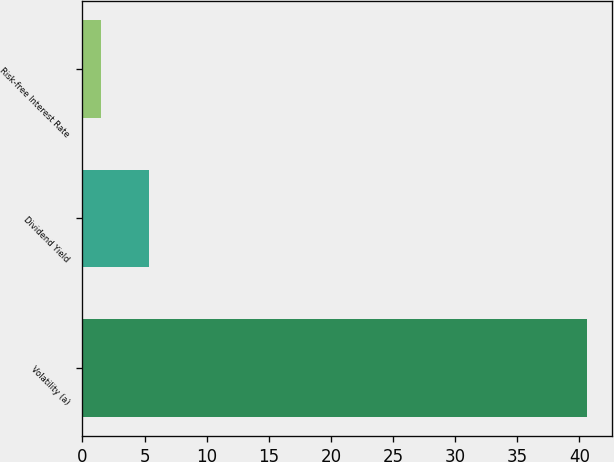Convert chart to OTSL. <chart><loc_0><loc_0><loc_500><loc_500><bar_chart><fcel>Volatility (a)<fcel>Dividend Yield<fcel>Risk-free Interest Rate<nl><fcel>40.6<fcel>5.38<fcel>1.47<nl></chart> 